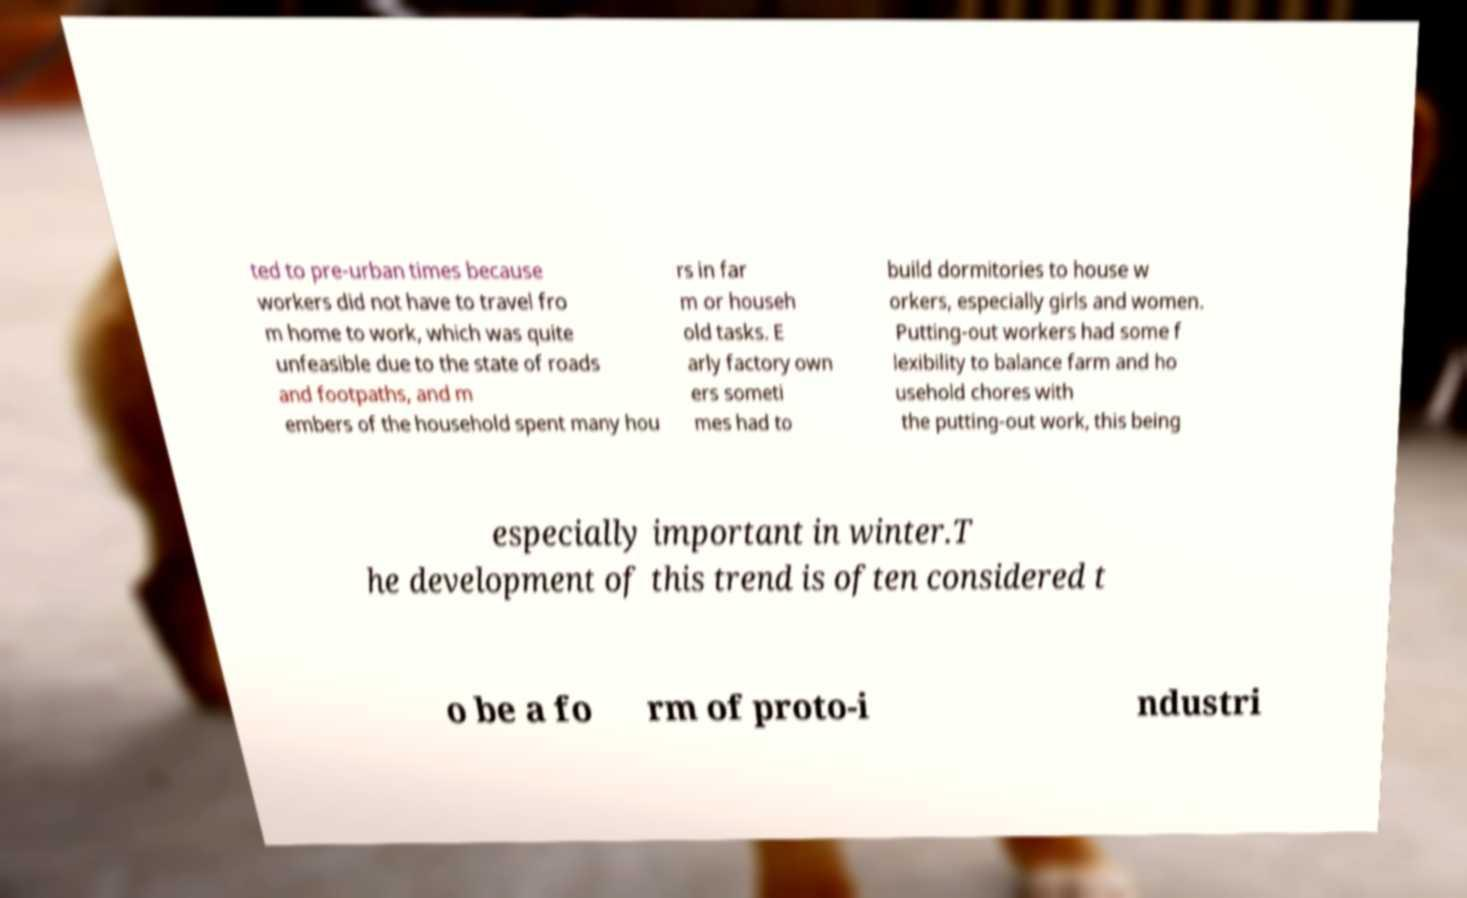Could you extract and type out the text from this image? ted to pre-urban times because workers did not have to travel fro m home to work, which was quite unfeasible due to the state of roads and footpaths, and m embers of the household spent many hou rs in far m or househ old tasks. E arly factory own ers someti mes had to build dormitories to house w orkers, especially girls and women. Putting-out workers had some f lexibility to balance farm and ho usehold chores with the putting-out work, this being especially important in winter.T he development of this trend is often considered t o be a fo rm of proto-i ndustri 